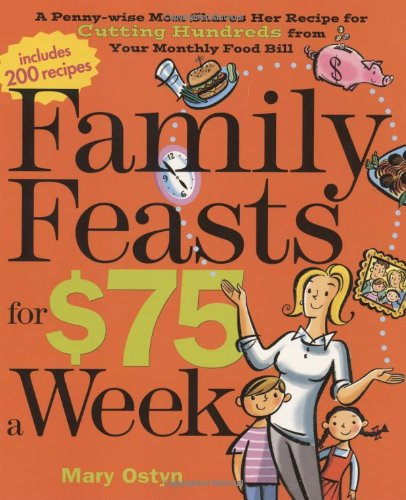What type of book is this? This book falls under the 'Cookbooks, Food & Wine' category, specifically targeting cost-effective cooking solutions for families. 